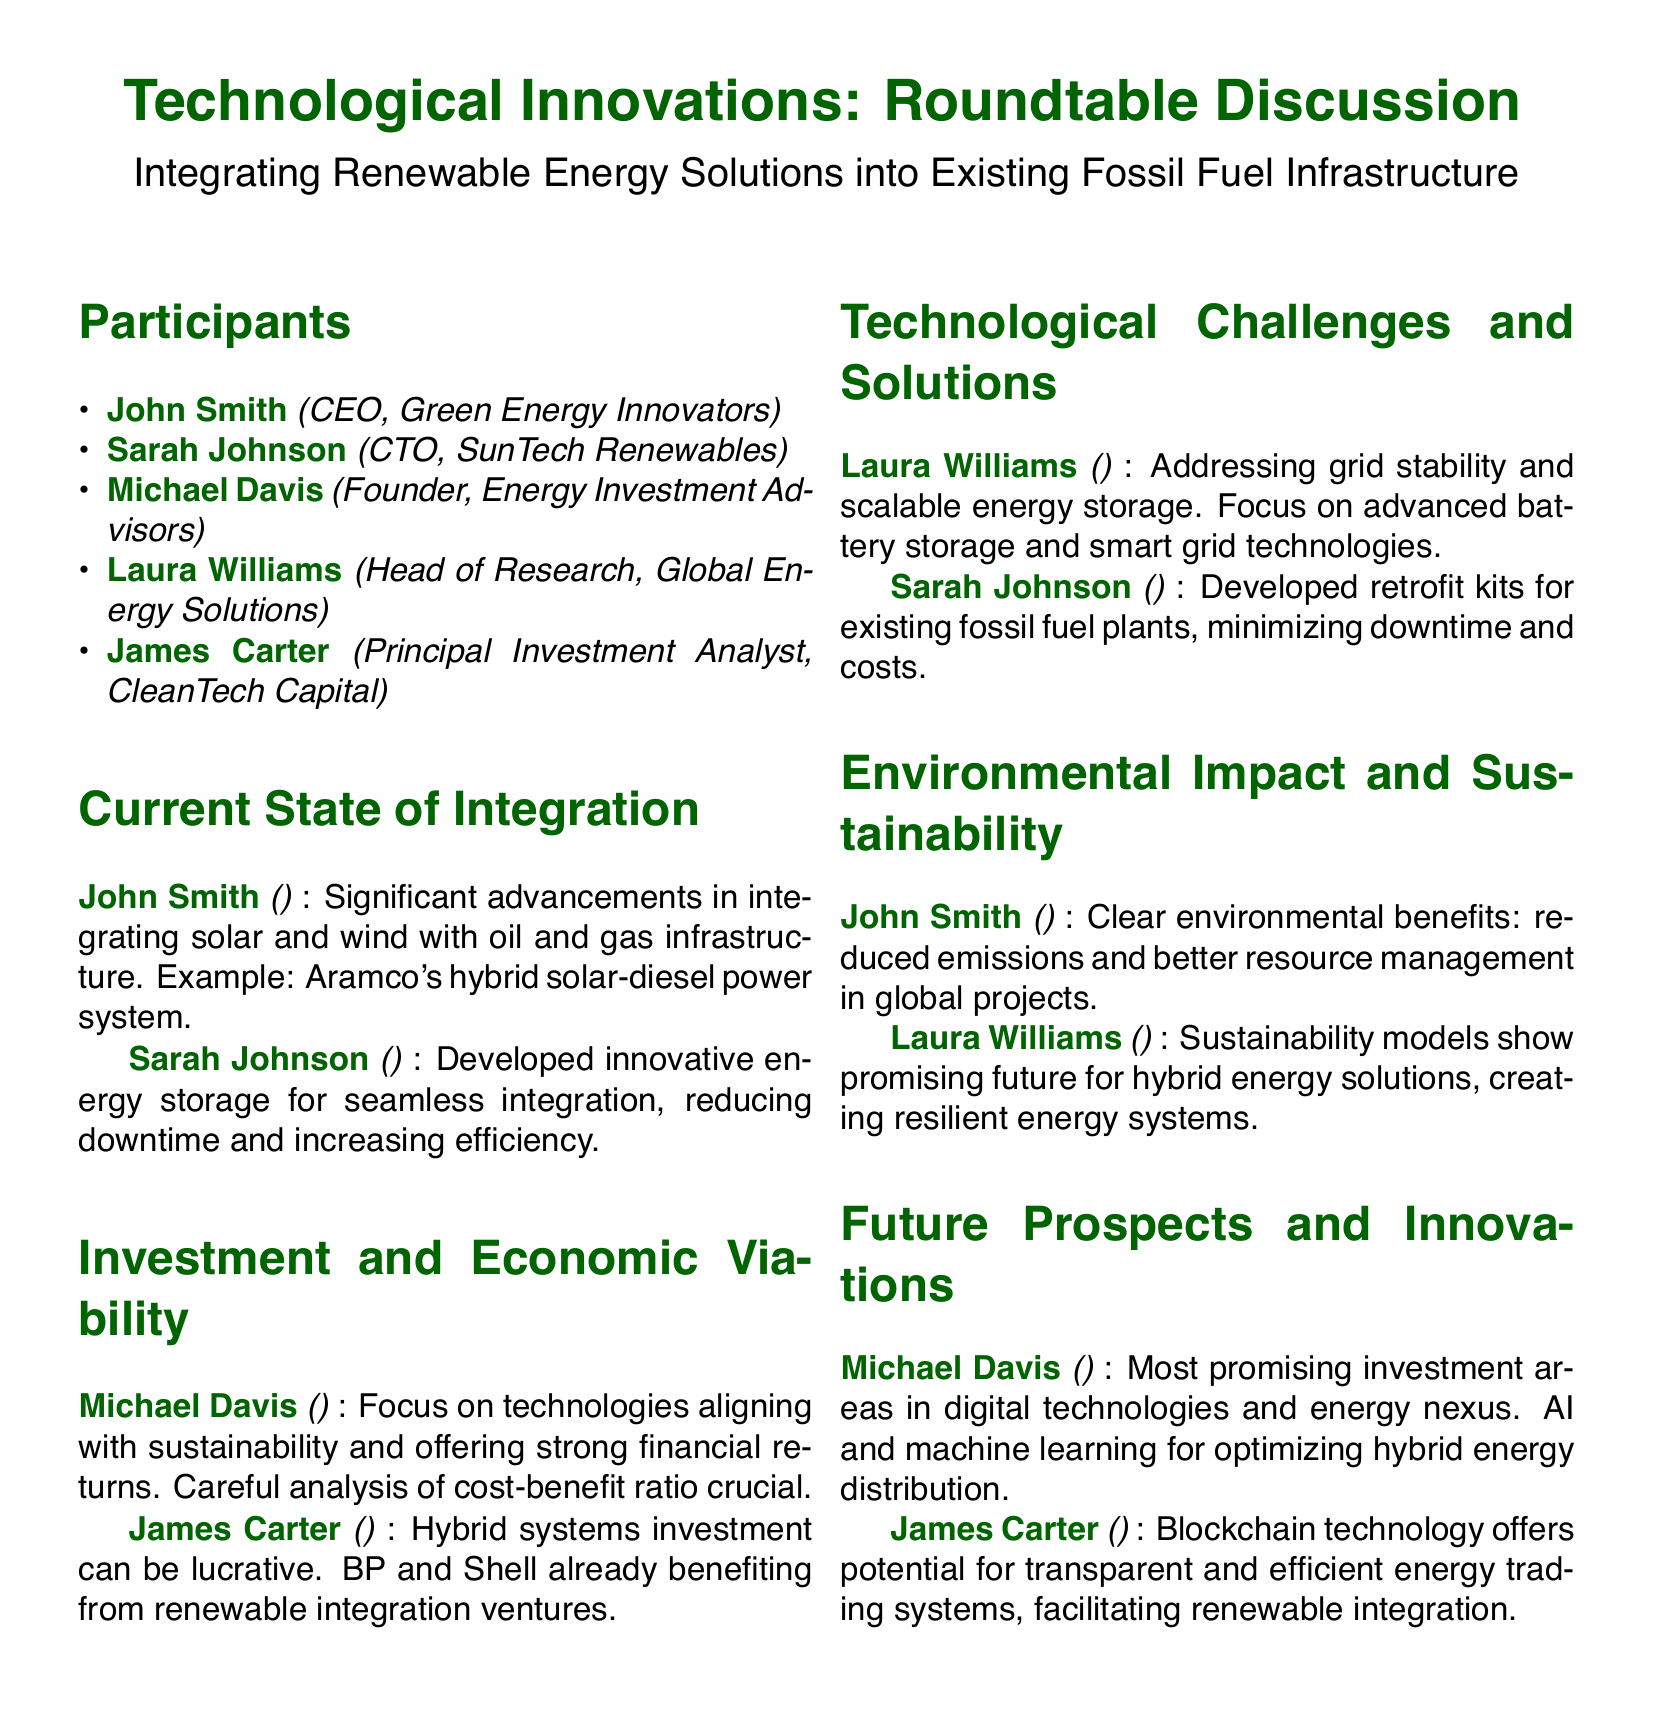What is the title of the roundtable discussion? The title is clearly stated in the document as "Technological Innovations: Roundtable Discussion."
Answer: Technological Innovations: Roundtable Discussion Who is the CTO of SunTech Renewables? The participant list provides the name and title of Sarah Johnson as the CTO of SunTech Renewables.
Answer: Sarah Johnson What significant advancement did John Smith mention? John Smith highlights significant advancements in integrating solar and wind with oil and gas infrastructure.
Answer: Hybrid solar-diesel power system Which technology is essential for grid stability according to Laura Williams? Laura Williams mentions that advanced battery storage and smart grid technologies are key to addressing grid stability.
Answer: Advanced battery storage What investment area does Michael Davis find promising? Michael Davis points out that digital technologies and energy nexus are promising investment areas.
Answer: Digital technologies Which technology offers potential for energy trading systems? James Carter states that blockchain technology offers potential for transparent and efficient energy trading systems.
Answer: Blockchain technology What was noted as a clear environmental benefit by John Smith? John Smith notes that reduced emissions is a clear environmental benefit in global projects.
Answer: Reduced emissions What type of kits has Sarah Johnson developed for existing fossil fuel plants? Sarah Johnson has developed retrofit kits for existing fossil fuel plants.
Answer: Retrofit kits 